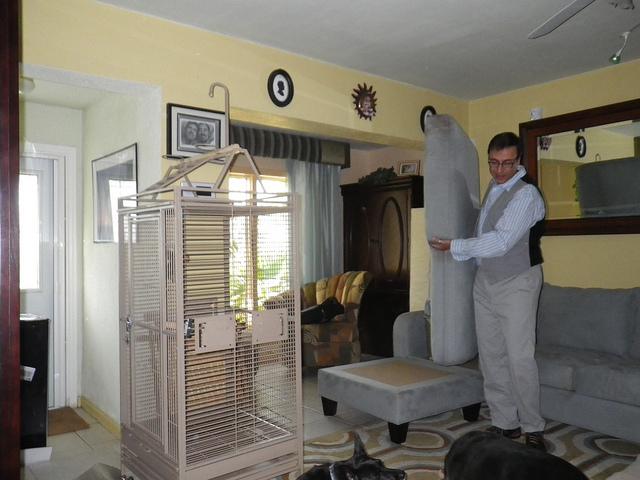Does this look like a woman's room?
Short answer required. No. What furniture is in the picture?
Short answer required. Couch. Are there any bright colors in here?
Quick response, please. Yes. What is inside the cage?
Be succinct. Bird. What is the man holding?
Short answer required. Cushion. What color are the curtains?
Write a very short answer. White. The man is holding a cushion?
Concise answer only. Yes. Do people use this object to travel with?
Be succinct. No. What part of the house is this?
Quick response, please. Living room. Are there any people in this picture?
Keep it brief. Yes. What is the man touching?
Give a very brief answer. Cushion. 